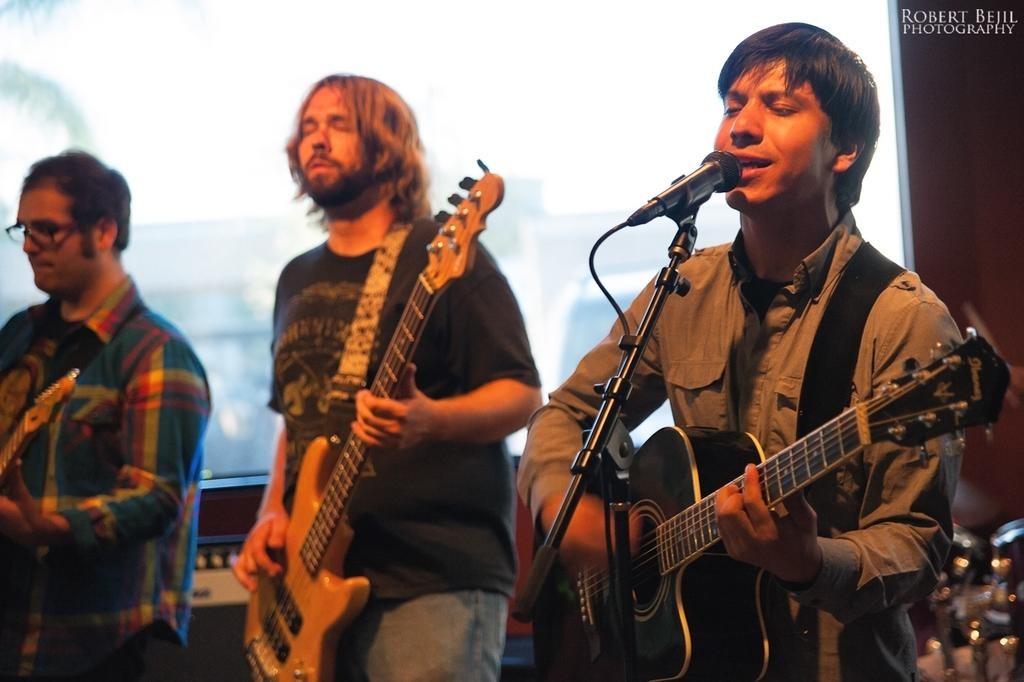How many people are in the image? There are three persons in the image. What are the persons doing in the image? The persons are standing, and one of them is playing a guitar. What can be seen in the background of the image? There is a tree and a building in the background of the image. What type of religious ceremony is taking place in the image? There is no indication of a religious ceremony in the image; it features three people standing, with one playing a guitar. Can you tell me where the vase is located in the image? There is no vase present in the image. 